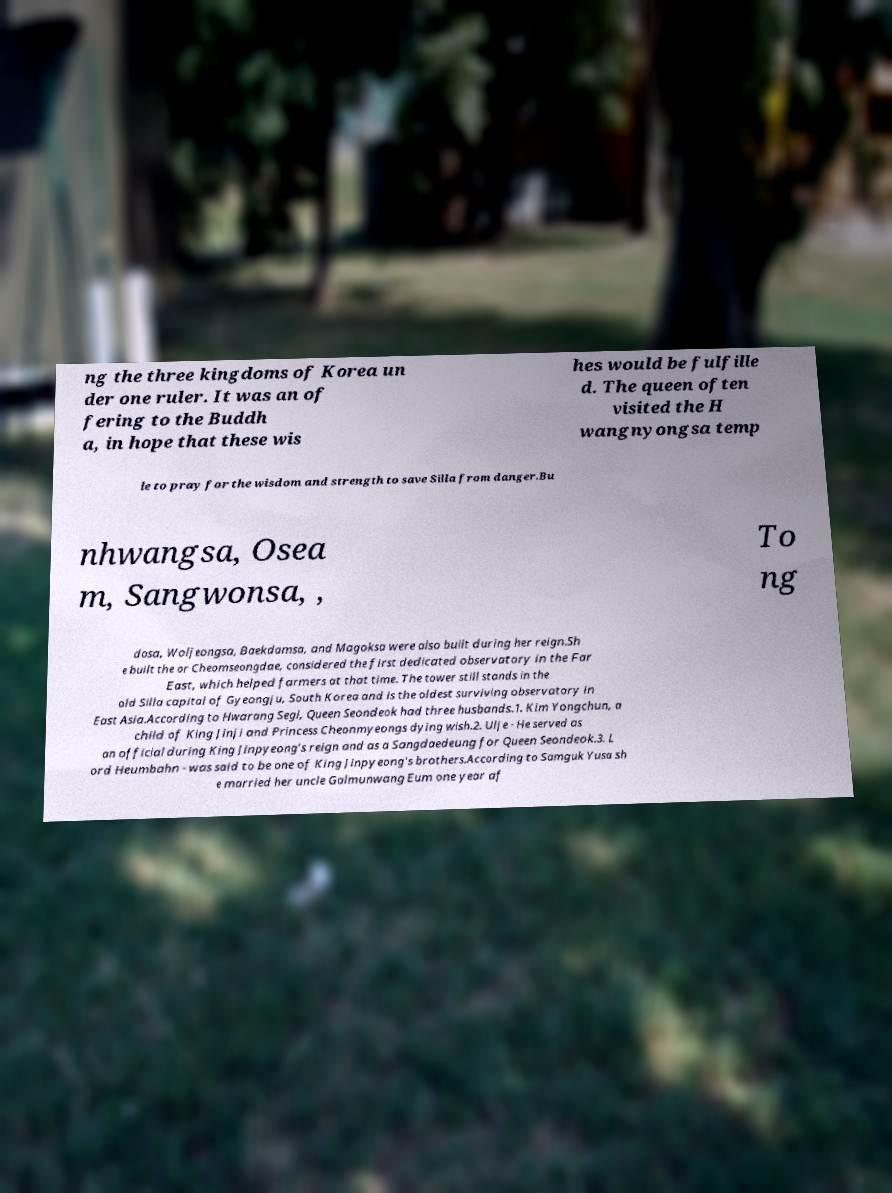What messages or text are displayed in this image? I need them in a readable, typed format. ng the three kingdoms of Korea un der one ruler. It was an of fering to the Buddh a, in hope that these wis hes would be fulfille d. The queen often visited the H wangnyongsa temp le to pray for the wisdom and strength to save Silla from danger.Bu nhwangsa, Osea m, Sangwonsa, , To ng dosa, Woljeongsa, Baekdamsa, and Magoksa were also built during her reign.Sh e built the or Cheomseongdae, considered the first dedicated observatory in the Far East, which helped farmers at that time. The tower still stands in the old Silla capital of Gyeongju, South Korea and is the oldest surviving observatory in East Asia.According to Hwarang Segi, Queen Seondeok had three husbands.1. Kim Yongchun, a child of King Jinji and Princess Cheonmyeongs dying wish.2. Ulje - He served as an official during King Jinpyeong's reign and as a Sangdaedeung for Queen Seondeok.3. L ord Heumbahn - was said to be one of King Jinpyeong's brothers.According to Samguk Yusa sh e married her uncle Galmunwang Eum one year af 